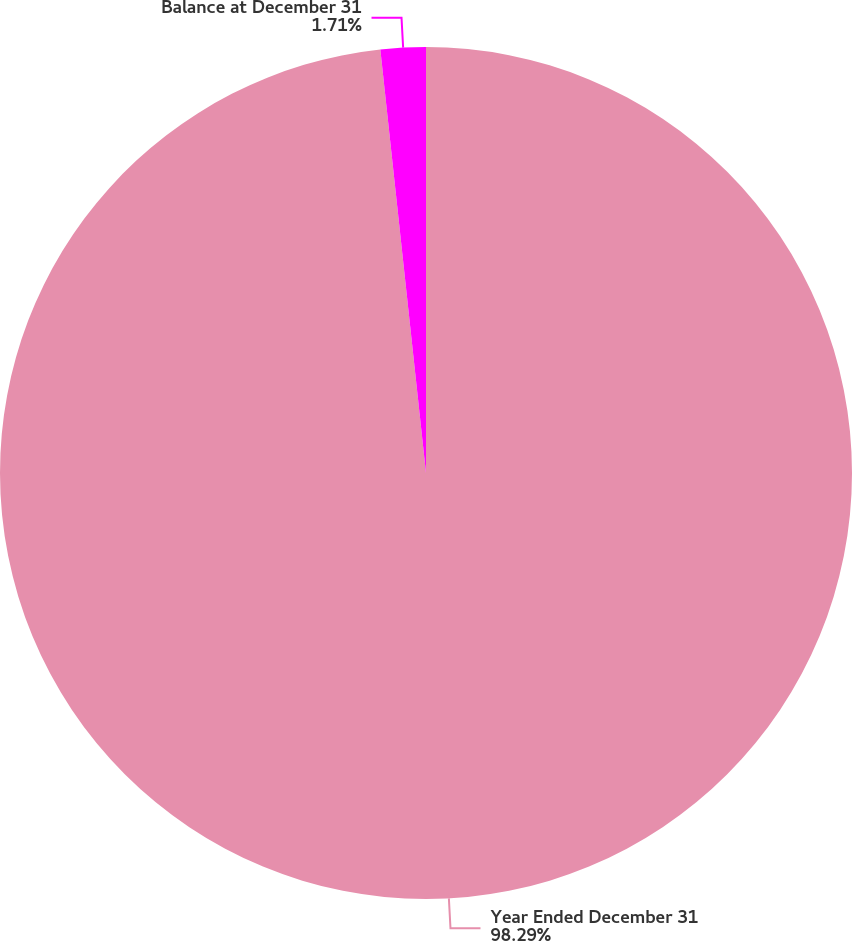Convert chart. <chart><loc_0><loc_0><loc_500><loc_500><pie_chart><fcel>Year Ended December 31<fcel>Balance at December 31<nl><fcel>98.29%<fcel>1.71%<nl></chart> 